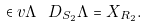Convert formula to latex. <formula><loc_0><loc_0><loc_500><loc_500>\in v { \Lambda } \ D _ { S _ { 2 } } \Lambda = X _ { R _ { 2 } } .</formula> 